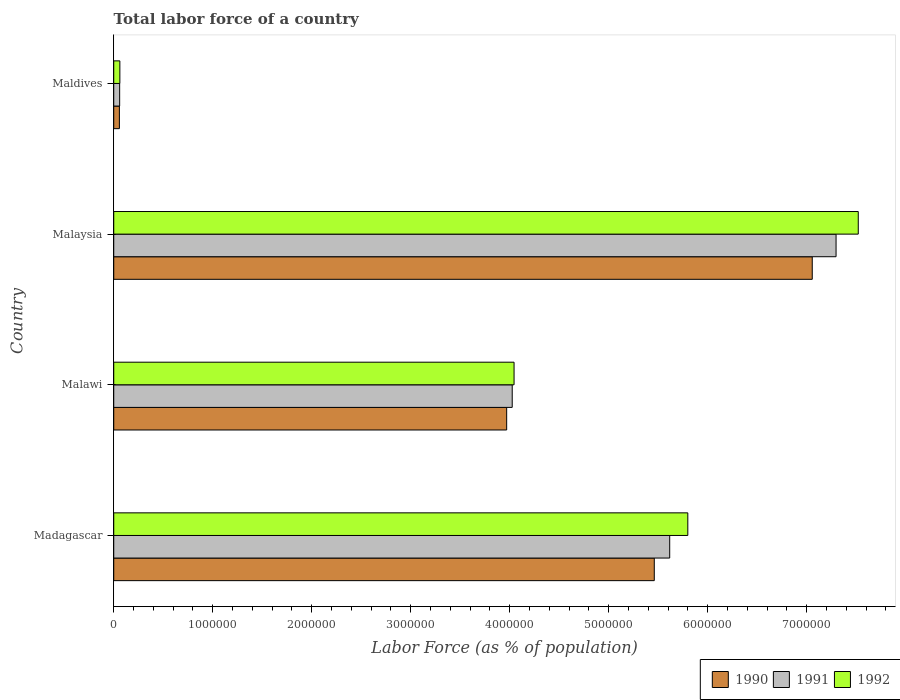Are the number of bars per tick equal to the number of legend labels?
Ensure brevity in your answer.  Yes. How many bars are there on the 4th tick from the top?
Keep it short and to the point. 3. What is the label of the 4th group of bars from the top?
Your answer should be compact. Madagascar. In how many cases, is the number of bars for a given country not equal to the number of legend labels?
Keep it short and to the point. 0. What is the percentage of labor force in 1992 in Maldives?
Provide a short and direct response. 6.18e+04. Across all countries, what is the maximum percentage of labor force in 1990?
Provide a succinct answer. 7.06e+06. Across all countries, what is the minimum percentage of labor force in 1990?
Give a very brief answer. 5.71e+04. In which country was the percentage of labor force in 1991 maximum?
Provide a short and direct response. Malaysia. In which country was the percentage of labor force in 1992 minimum?
Offer a very short reply. Maldives. What is the total percentage of labor force in 1990 in the graph?
Your answer should be compact. 1.65e+07. What is the difference between the percentage of labor force in 1991 in Malaysia and that in Maldives?
Offer a very short reply. 7.24e+06. What is the difference between the percentage of labor force in 1990 in Malawi and the percentage of labor force in 1991 in Maldives?
Give a very brief answer. 3.91e+06. What is the average percentage of labor force in 1990 per country?
Offer a terse response. 4.14e+06. What is the difference between the percentage of labor force in 1990 and percentage of labor force in 1991 in Malawi?
Keep it short and to the point. -5.61e+04. What is the ratio of the percentage of labor force in 1990 in Malawi to that in Maldives?
Offer a very short reply. 69.52. Is the difference between the percentage of labor force in 1990 in Madagascar and Maldives greater than the difference between the percentage of labor force in 1991 in Madagascar and Maldives?
Your answer should be very brief. No. What is the difference between the highest and the second highest percentage of labor force in 1992?
Provide a succinct answer. 1.72e+06. What is the difference between the highest and the lowest percentage of labor force in 1992?
Your answer should be very brief. 7.46e+06. In how many countries, is the percentage of labor force in 1992 greater than the average percentage of labor force in 1992 taken over all countries?
Ensure brevity in your answer.  2. Is the sum of the percentage of labor force in 1991 in Malawi and Malaysia greater than the maximum percentage of labor force in 1990 across all countries?
Make the answer very short. Yes. What does the 3rd bar from the top in Madagascar represents?
Make the answer very short. 1990. What does the 2nd bar from the bottom in Malawi represents?
Offer a terse response. 1991. Is it the case that in every country, the sum of the percentage of labor force in 1990 and percentage of labor force in 1992 is greater than the percentage of labor force in 1991?
Make the answer very short. Yes. How many bars are there?
Your response must be concise. 12. Does the graph contain any zero values?
Keep it short and to the point. No. Does the graph contain grids?
Provide a succinct answer. No. Where does the legend appear in the graph?
Offer a very short reply. Bottom right. How are the legend labels stacked?
Provide a short and direct response. Horizontal. What is the title of the graph?
Provide a short and direct response. Total labor force of a country. What is the label or title of the X-axis?
Offer a very short reply. Labor Force (as % of population). What is the label or title of the Y-axis?
Keep it short and to the point. Country. What is the Labor Force (as % of population) of 1990 in Madagascar?
Make the answer very short. 5.46e+06. What is the Labor Force (as % of population) in 1991 in Madagascar?
Give a very brief answer. 5.62e+06. What is the Labor Force (as % of population) in 1992 in Madagascar?
Provide a succinct answer. 5.80e+06. What is the Labor Force (as % of population) in 1990 in Malawi?
Your answer should be compact. 3.97e+06. What is the Labor Force (as % of population) in 1991 in Malawi?
Provide a short and direct response. 4.03e+06. What is the Labor Force (as % of population) in 1992 in Malawi?
Your response must be concise. 4.04e+06. What is the Labor Force (as % of population) of 1990 in Malaysia?
Your answer should be compact. 7.06e+06. What is the Labor Force (as % of population) in 1991 in Malaysia?
Your response must be concise. 7.30e+06. What is the Labor Force (as % of population) in 1992 in Malaysia?
Keep it short and to the point. 7.52e+06. What is the Labor Force (as % of population) of 1990 in Maldives?
Make the answer very short. 5.71e+04. What is the Labor Force (as % of population) in 1991 in Maldives?
Your answer should be very brief. 5.97e+04. What is the Labor Force (as % of population) in 1992 in Maldives?
Give a very brief answer. 6.18e+04. Across all countries, what is the maximum Labor Force (as % of population) of 1990?
Your answer should be very brief. 7.06e+06. Across all countries, what is the maximum Labor Force (as % of population) in 1991?
Provide a succinct answer. 7.30e+06. Across all countries, what is the maximum Labor Force (as % of population) in 1992?
Keep it short and to the point. 7.52e+06. Across all countries, what is the minimum Labor Force (as % of population) of 1990?
Ensure brevity in your answer.  5.71e+04. Across all countries, what is the minimum Labor Force (as % of population) of 1991?
Your answer should be compact. 5.97e+04. Across all countries, what is the minimum Labor Force (as % of population) in 1992?
Make the answer very short. 6.18e+04. What is the total Labor Force (as % of population) of 1990 in the graph?
Your answer should be compact. 1.65e+07. What is the total Labor Force (as % of population) in 1991 in the graph?
Provide a succinct answer. 1.70e+07. What is the total Labor Force (as % of population) of 1992 in the graph?
Your response must be concise. 1.74e+07. What is the difference between the Labor Force (as % of population) of 1990 in Madagascar and that in Malawi?
Your answer should be very brief. 1.49e+06. What is the difference between the Labor Force (as % of population) of 1991 in Madagascar and that in Malawi?
Offer a terse response. 1.59e+06. What is the difference between the Labor Force (as % of population) of 1992 in Madagascar and that in Malawi?
Your answer should be very brief. 1.76e+06. What is the difference between the Labor Force (as % of population) in 1990 in Madagascar and that in Malaysia?
Keep it short and to the point. -1.60e+06. What is the difference between the Labor Force (as % of population) in 1991 in Madagascar and that in Malaysia?
Provide a succinct answer. -1.68e+06. What is the difference between the Labor Force (as % of population) in 1992 in Madagascar and that in Malaysia?
Offer a very short reply. -1.72e+06. What is the difference between the Labor Force (as % of population) of 1990 in Madagascar and that in Maldives?
Provide a succinct answer. 5.40e+06. What is the difference between the Labor Force (as % of population) in 1991 in Madagascar and that in Maldives?
Provide a succinct answer. 5.56e+06. What is the difference between the Labor Force (as % of population) of 1992 in Madagascar and that in Maldives?
Make the answer very short. 5.74e+06. What is the difference between the Labor Force (as % of population) of 1990 in Malawi and that in Malaysia?
Give a very brief answer. -3.09e+06. What is the difference between the Labor Force (as % of population) of 1991 in Malawi and that in Malaysia?
Offer a very short reply. -3.27e+06. What is the difference between the Labor Force (as % of population) in 1992 in Malawi and that in Malaysia?
Provide a succinct answer. -3.48e+06. What is the difference between the Labor Force (as % of population) of 1990 in Malawi and that in Maldives?
Your response must be concise. 3.91e+06. What is the difference between the Labor Force (as % of population) of 1991 in Malawi and that in Maldives?
Make the answer very short. 3.97e+06. What is the difference between the Labor Force (as % of population) of 1992 in Malawi and that in Maldives?
Provide a short and direct response. 3.98e+06. What is the difference between the Labor Force (as % of population) in 1990 in Malaysia and that in Maldives?
Your answer should be compact. 7.00e+06. What is the difference between the Labor Force (as % of population) of 1991 in Malaysia and that in Maldives?
Ensure brevity in your answer.  7.24e+06. What is the difference between the Labor Force (as % of population) in 1992 in Malaysia and that in Maldives?
Provide a short and direct response. 7.46e+06. What is the difference between the Labor Force (as % of population) in 1990 in Madagascar and the Labor Force (as % of population) in 1991 in Malawi?
Keep it short and to the point. 1.44e+06. What is the difference between the Labor Force (as % of population) in 1990 in Madagascar and the Labor Force (as % of population) in 1992 in Malawi?
Make the answer very short. 1.42e+06. What is the difference between the Labor Force (as % of population) of 1991 in Madagascar and the Labor Force (as % of population) of 1992 in Malawi?
Your response must be concise. 1.57e+06. What is the difference between the Labor Force (as % of population) in 1990 in Madagascar and the Labor Force (as % of population) in 1991 in Malaysia?
Your answer should be compact. -1.84e+06. What is the difference between the Labor Force (as % of population) in 1990 in Madagascar and the Labor Force (as % of population) in 1992 in Malaysia?
Provide a succinct answer. -2.06e+06. What is the difference between the Labor Force (as % of population) of 1991 in Madagascar and the Labor Force (as % of population) of 1992 in Malaysia?
Your answer should be compact. -1.90e+06. What is the difference between the Labor Force (as % of population) in 1990 in Madagascar and the Labor Force (as % of population) in 1991 in Maldives?
Provide a short and direct response. 5.40e+06. What is the difference between the Labor Force (as % of population) in 1990 in Madagascar and the Labor Force (as % of population) in 1992 in Maldives?
Ensure brevity in your answer.  5.40e+06. What is the difference between the Labor Force (as % of population) in 1991 in Madagascar and the Labor Force (as % of population) in 1992 in Maldives?
Provide a succinct answer. 5.55e+06. What is the difference between the Labor Force (as % of population) of 1990 in Malawi and the Labor Force (as % of population) of 1991 in Malaysia?
Make the answer very short. -3.33e+06. What is the difference between the Labor Force (as % of population) in 1990 in Malawi and the Labor Force (as % of population) in 1992 in Malaysia?
Give a very brief answer. -3.55e+06. What is the difference between the Labor Force (as % of population) of 1991 in Malawi and the Labor Force (as % of population) of 1992 in Malaysia?
Ensure brevity in your answer.  -3.50e+06. What is the difference between the Labor Force (as % of population) of 1990 in Malawi and the Labor Force (as % of population) of 1991 in Maldives?
Provide a succinct answer. 3.91e+06. What is the difference between the Labor Force (as % of population) of 1990 in Malawi and the Labor Force (as % of population) of 1992 in Maldives?
Your answer should be very brief. 3.91e+06. What is the difference between the Labor Force (as % of population) in 1991 in Malawi and the Labor Force (as % of population) in 1992 in Maldives?
Offer a very short reply. 3.96e+06. What is the difference between the Labor Force (as % of population) in 1990 in Malaysia and the Labor Force (as % of population) in 1991 in Maldives?
Provide a short and direct response. 7.00e+06. What is the difference between the Labor Force (as % of population) of 1990 in Malaysia and the Labor Force (as % of population) of 1992 in Maldives?
Ensure brevity in your answer.  6.99e+06. What is the difference between the Labor Force (as % of population) in 1991 in Malaysia and the Labor Force (as % of population) in 1992 in Maldives?
Provide a short and direct response. 7.24e+06. What is the average Labor Force (as % of population) of 1990 per country?
Provide a succinct answer. 4.14e+06. What is the average Labor Force (as % of population) in 1991 per country?
Ensure brevity in your answer.  4.25e+06. What is the average Labor Force (as % of population) in 1992 per country?
Give a very brief answer. 4.36e+06. What is the difference between the Labor Force (as % of population) of 1990 and Labor Force (as % of population) of 1991 in Madagascar?
Make the answer very short. -1.56e+05. What is the difference between the Labor Force (as % of population) of 1990 and Labor Force (as % of population) of 1992 in Madagascar?
Your response must be concise. -3.39e+05. What is the difference between the Labor Force (as % of population) in 1991 and Labor Force (as % of population) in 1992 in Madagascar?
Provide a succinct answer. -1.83e+05. What is the difference between the Labor Force (as % of population) of 1990 and Labor Force (as % of population) of 1991 in Malawi?
Offer a very short reply. -5.61e+04. What is the difference between the Labor Force (as % of population) of 1990 and Labor Force (as % of population) of 1992 in Malawi?
Your response must be concise. -7.47e+04. What is the difference between the Labor Force (as % of population) of 1991 and Labor Force (as % of population) of 1992 in Malawi?
Provide a short and direct response. -1.86e+04. What is the difference between the Labor Force (as % of population) in 1990 and Labor Force (as % of population) in 1991 in Malaysia?
Ensure brevity in your answer.  -2.40e+05. What is the difference between the Labor Force (as % of population) in 1990 and Labor Force (as % of population) in 1992 in Malaysia?
Your answer should be very brief. -4.65e+05. What is the difference between the Labor Force (as % of population) in 1991 and Labor Force (as % of population) in 1992 in Malaysia?
Your response must be concise. -2.24e+05. What is the difference between the Labor Force (as % of population) of 1990 and Labor Force (as % of population) of 1991 in Maldives?
Make the answer very short. -2582. What is the difference between the Labor Force (as % of population) of 1990 and Labor Force (as % of population) of 1992 in Maldives?
Ensure brevity in your answer.  -4710. What is the difference between the Labor Force (as % of population) of 1991 and Labor Force (as % of population) of 1992 in Maldives?
Provide a succinct answer. -2128. What is the ratio of the Labor Force (as % of population) of 1990 in Madagascar to that in Malawi?
Your answer should be very brief. 1.38. What is the ratio of the Labor Force (as % of population) in 1991 in Madagascar to that in Malawi?
Offer a very short reply. 1.4. What is the ratio of the Labor Force (as % of population) in 1992 in Madagascar to that in Malawi?
Offer a terse response. 1.43. What is the ratio of the Labor Force (as % of population) of 1990 in Madagascar to that in Malaysia?
Make the answer very short. 0.77. What is the ratio of the Labor Force (as % of population) of 1991 in Madagascar to that in Malaysia?
Provide a short and direct response. 0.77. What is the ratio of the Labor Force (as % of population) in 1992 in Madagascar to that in Malaysia?
Your response must be concise. 0.77. What is the ratio of the Labor Force (as % of population) in 1990 in Madagascar to that in Maldives?
Your answer should be compact. 95.64. What is the ratio of the Labor Force (as % of population) of 1991 in Madagascar to that in Maldives?
Give a very brief answer. 94.12. What is the ratio of the Labor Force (as % of population) in 1992 in Madagascar to that in Maldives?
Keep it short and to the point. 93.84. What is the ratio of the Labor Force (as % of population) of 1990 in Malawi to that in Malaysia?
Offer a terse response. 0.56. What is the ratio of the Labor Force (as % of population) of 1991 in Malawi to that in Malaysia?
Offer a terse response. 0.55. What is the ratio of the Labor Force (as % of population) in 1992 in Malawi to that in Malaysia?
Make the answer very short. 0.54. What is the ratio of the Labor Force (as % of population) in 1990 in Malawi to that in Maldives?
Your answer should be very brief. 69.52. What is the ratio of the Labor Force (as % of population) of 1991 in Malawi to that in Maldives?
Offer a terse response. 67.46. What is the ratio of the Labor Force (as % of population) in 1992 in Malawi to that in Maldives?
Make the answer very short. 65.43. What is the ratio of the Labor Force (as % of population) in 1990 in Malaysia to that in Maldives?
Your answer should be compact. 123.59. What is the ratio of the Labor Force (as % of population) in 1991 in Malaysia to that in Maldives?
Offer a very short reply. 122.28. What is the ratio of the Labor Force (as % of population) in 1992 in Malaysia to that in Maldives?
Offer a terse response. 121.7. What is the difference between the highest and the second highest Labor Force (as % of population) of 1990?
Make the answer very short. 1.60e+06. What is the difference between the highest and the second highest Labor Force (as % of population) of 1991?
Your answer should be very brief. 1.68e+06. What is the difference between the highest and the second highest Labor Force (as % of population) in 1992?
Make the answer very short. 1.72e+06. What is the difference between the highest and the lowest Labor Force (as % of population) of 1990?
Offer a terse response. 7.00e+06. What is the difference between the highest and the lowest Labor Force (as % of population) of 1991?
Keep it short and to the point. 7.24e+06. What is the difference between the highest and the lowest Labor Force (as % of population) in 1992?
Provide a succinct answer. 7.46e+06. 